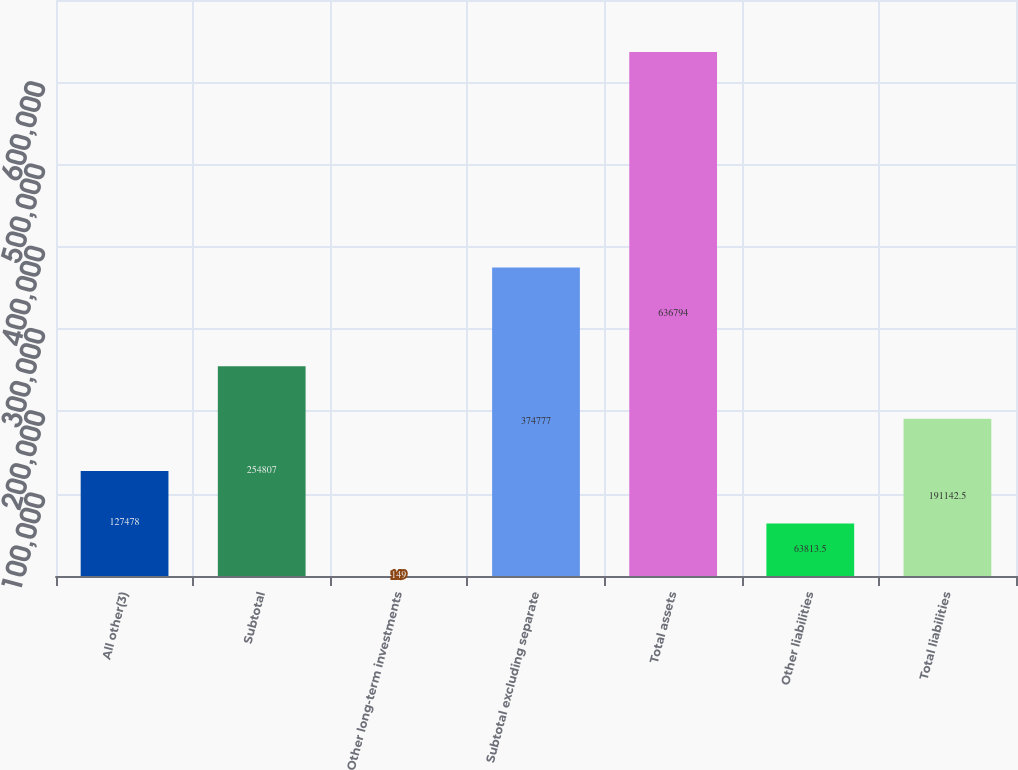Convert chart to OTSL. <chart><loc_0><loc_0><loc_500><loc_500><bar_chart><fcel>All other(3)<fcel>Subtotal<fcel>Other long-term investments<fcel>Subtotal excluding separate<fcel>Total assets<fcel>Other liabilities<fcel>Total liabilities<nl><fcel>127478<fcel>254807<fcel>149<fcel>374777<fcel>636794<fcel>63813.5<fcel>191142<nl></chart> 